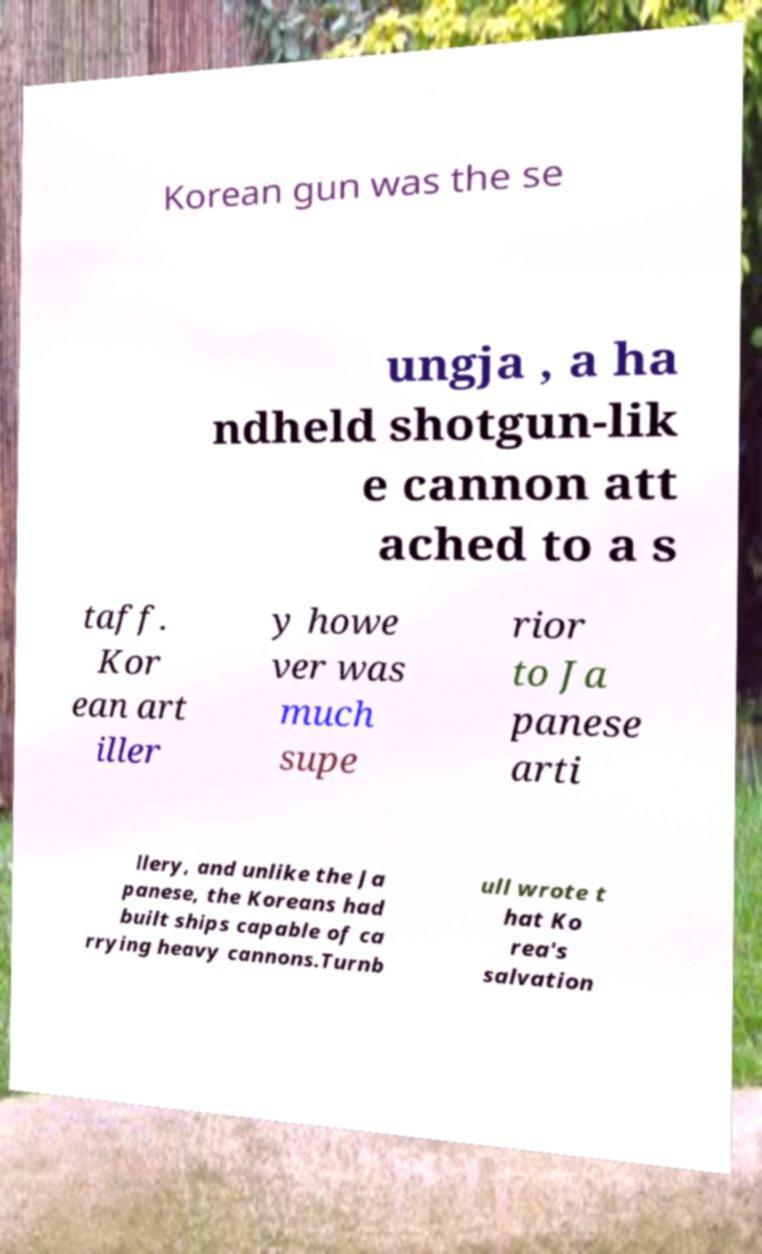Could you extract and type out the text from this image? Korean gun was the se ungja , a ha ndheld shotgun-lik e cannon att ached to a s taff. Kor ean art iller y howe ver was much supe rior to Ja panese arti llery, and unlike the Ja panese, the Koreans had built ships capable of ca rrying heavy cannons.Turnb ull wrote t hat Ko rea's salvation 